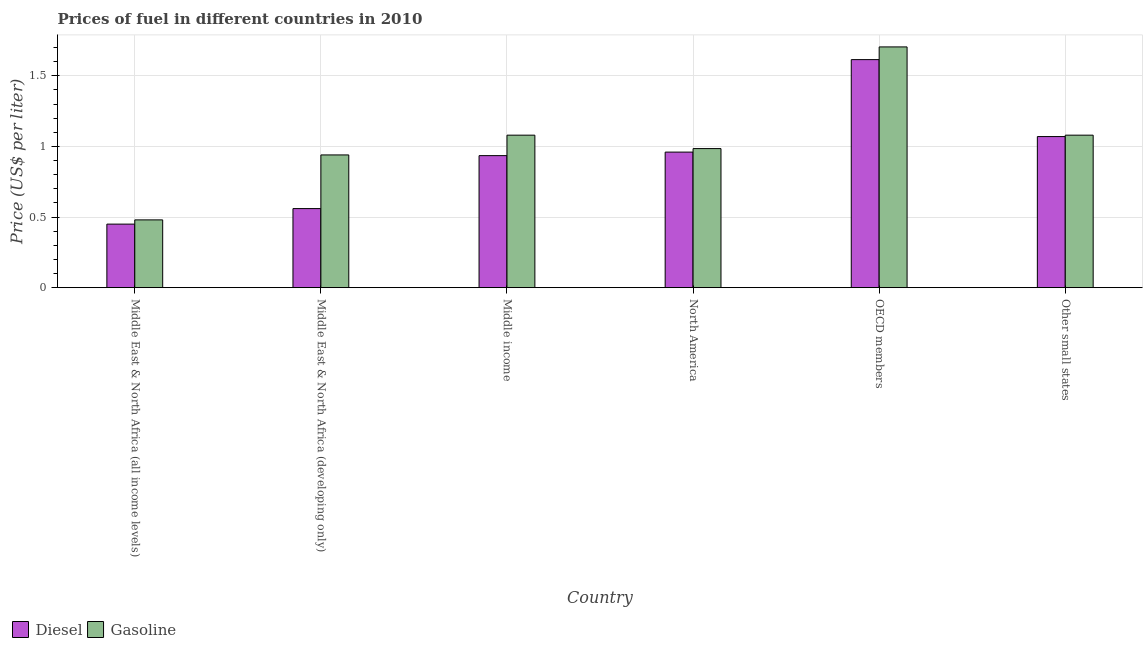How many different coloured bars are there?
Provide a succinct answer. 2. How many groups of bars are there?
Offer a terse response. 6. Are the number of bars per tick equal to the number of legend labels?
Provide a succinct answer. Yes. Are the number of bars on each tick of the X-axis equal?
Your response must be concise. Yes. What is the label of the 5th group of bars from the left?
Keep it short and to the point. OECD members. What is the gasoline price in Middle East & North Africa (all income levels)?
Offer a terse response. 0.48. Across all countries, what is the maximum diesel price?
Provide a short and direct response. 1.61. Across all countries, what is the minimum gasoline price?
Your answer should be very brief. 0.48. In which country was the gasoline price minimum?
Provide a short and direct response. Middle East & North Africa (all income levels). What is the total gasoline price in the graph?
Your response must be concise. 6.27. What is the difference between the gasoline price in Middle East & North Africa (all income levels) and that in OECD members?
Your answer should be compact. -1.23. What is the difference between the gasoline price in OECD members and the diesel price in Middle East & North Africa (all income levels)?
Your answer should be compact. 1.26. What is the average diesel price per country?
Your answer should be compact. 0.93. What is the difference between the diesel price and gasoline price in OECD members?
Make the answer very short. -0.09. In how many countries, is the diesel price greater than 1.3 US$ per litre?
Keep it short and to the point. 1. What is the ratio of the diesel price in Middle East & North Africa (all income levels) to that in Other small states?
Give a very brief answer. 0.42. Is the diesel price in Middle East & North Africa (all income levels) less than that in Middle income?
Make the answer very short. Yes. Is the difference between the gasoline price in North America and OECD members greater than the difference between the diesel price in North America and OECD members?
Give a very brief answer. No. What is the difference between the highest and the second highest diesel price?
Make the answer very short. 0.54. What is the difference between the highest and the lowest gasoline price?
Provide a short and direct response. 1.23. Is the sum of the diesel price in Middle East & North Africa (all income levels) and Middle East & North Africa (developing only) greater than the maximum gasoline price across all countries?
Keep it short and to the point. No. What does the 1st bar from the left in Other small states represents?
Your answer should be very brief. Diesel. What does the 2nd bar from the right in OECD members represents?
Give a very brief answer. Diesel. What is the difference between two consecutive major ticks on the Y-axis?
Provide a succinct answer. 0.5. Does the graph contain grids?
Give a very brief answer. Yes. Where does the legend appear in the graph?
Your response must be concise. Bottom left. How many legend labels are there?
Provide a succinct answer. 2. What is the title of the graph?
Ensure brevity in your answer.  Prices of fuel in different countries in 2010. Does "Borrowers" appear as one of the legend labels in the graph?
Provide a succinct answer. No. What is the label or title of the X-axis?
Make the answer very short. Country. What is the label or title of the Y-axis?
Offer a very short reply. Price (US$ per liter). What is the Price (US$ per liter) in Diesel in Middle East & North Africa (all income levels)?
Make the answer very short. 0.45. What is the Price (US$ per liter) of Gasoline in Middle East & North Africa (all income levels)?
Offer a terse response. 0.48. What is the Price (US$ per liter) in Diesel in Middle East & North Africa (developing only)?
Offer a very short reply. 0.56. What is the Price (US$ per liter) in Gasoline in Middle East & North Africa (developing only)?
Provide a succinct answer. 0.94. What is the Price (US$ per liter) of Diesel in Middle income?
Keep it short and to the point. 0.94. What is the Price (US$ per liter) of Gasoline in Middle income?
Provide a succinct answer. 1.08. What is the Price (US$ per liter) in Diesel in North America?
Offer a terse response. 0.96. What is the Price (US$ per liter) in Gasoline in North America?
Make the answer very short. 0.98. What is the Price (US$ per liter) in Diesel in OECD members?
Provide a short and direct response. 1.61. What is the Price (US$ per liter) of Gasoline in OECD members?
Your answer should be very brief. 1.71. What is the Price (US$ per liter) of Diesel in Other small states?
Your answer should be compact. 1.07. Across all countries, what is the maximum Price (US$ per liter) in Diesel?
Provide a short and direct response. 1.61. Across all countries, what is the maximum Price (US$ per liter) of Gasoline?
Keep it short and to the point. 1.71. Across all countries, what is the minimum Price (US$ per liter) in Diesel?
Provide a succinct answer. 0.45. Across all countries, what is the minimum Price (US$ per liter) in Gasoline?
Your answer should be compact. 0.48. What is the total Price (US$ per liter) of Diesel in the graph?
Your answer should be very brief. 5.59. What is the total Price (US$ per liter) of Gasoline in the graph?
Your response must be concise. 6.27. What is the difference between the Price (US$ per liter) in Diesel in Middle East & North Africa (all income levels) and that in Middle East & North Africa (developing only)?
Offer a terse response. -0.11. What is the difference between the Price (US$ per liter) of Gasoline in Middle East & North Africa (all income levels) and that in Middle East & North Africa (developing only)?
Provide a short and direct response. -0.46. What is the difference between the Price (US$ per liter) of Diesel in Middle East & North Africa (all income levels) and that in Middle income?
Make the answer very short. -0.48. What is the difference between the Price (US$ per liter) of Gasoline in Middle East & North Africa (all income levels) and that in Middle income?
Give a very brief answer. -0.6. What is the difference between the Price (US$ per liter) of Diesel in Middle East & North Africa (all income levels) and that in North America?
Make the answer very short. -0.51. What is the difference between the Price (US$ per liter) of Gasoline in Middle East & North Africa (all income levels) and that in North America?
Offer a terse response. -0.51. What is the difference between the Price (US$ per liter) in Diesel in Middle East & North Africa (all income levels) and that in OECD members?
Your response must be concise. -1.17. What is the difference between the Price (US$ per liter) in Gasoline in Middle East & North Africa (all income levels) and that in OECD members?
Your answer should be very brief. -1.23. What is the difference between the Price (US$ per liter) in Diesel in Middle East & North Africa (all income levels) and that in Other small states?
Keep it short and to the point. -0.62. What is the difference between the Price (US$ per liter) of Diesel in Middle East & North Africa (developing only) and that in Middle income?
Your answer should be very brief. -0.38. What is the difference between the Price (US$ per liter) of Gasoline in Middle East & North Africa (developing only) and that in Middle income?
Offer a terse response. -0.14. What is the difference between the Price (US$ per liter) of Diesel in Middle East & North Africa (developing only) and that in North America?
Make the answer very short. -0.4. What is the difference between the Price (US$ per liter) in Gasoline in Middle East & North Africa (developing only) and that in North America?
Make the answer very short. -0.04. What is the difference between the Price (US$ per liter) in Diesel in Middle East & North Africa (developing only) and that in OECD members?
Offer a terse response. -1.05. What is the difference between the Price (US$ per liter) in Gasoline in Middle East & North Africa (developing only) and that in OECD members?
Offer a terse response. -0.77. What is the difference between the Price (US$ per liter) of Diesel in Middle East & North Africa (developing only) and that in Other small states?
Your answer should be compact. -0.51. What is the difference between the Price (US$ per liter) in Gasoline in Middle East & North Africa (developing only) and that in Other small states?
Give a very brief answer. -0.14. What is the difference between the Price (US$ per liter) in Diesel in Middle income and that in North America?
Provide a succinct answer. -0.03. What is the difference between the Price (US$ per liter) of Gasoline in Middle income and that in North America?
Make the answer very short. 0.1. What is the difference between the Price (US$ per liter) of Diesel in Middle income and that in OECD members?
Offer a terse response. -0.68. What is the difference between the Price (US$ per liter) in Gasoline in Middle income and that in OECD members?
Your answer should be very brief. -0.62. What is the difference between the Price (US$ per liter) of Diesel in Middle income and that in Other small states?
Keep it short and to the point. -0.14. What is the difference between the Price (US$ per liter) of Diesel in North America and that in OECD members?
Keep it short and to the point. -0.66. What is the difference between the Price (US$ per liter) in Gasoline in North America and that in OECD members?
Make the answer very short. -0.72. What is the difference between the Price (US$ per liter) of Diesel in North America and that in Other small states?
Your answer should be very brief. -0.11. What is the difference between the Price (US$ per liter) of Gasoline in North America and that in Other small states?
Provide a succinct answer. -0.1. What is the difference between the Price (US$ per liter) in Diesel in OECD members and that in Other small states?
Your response must be concise. 0.55. What is the difference between the Price (US$ per liter) in Gasoline in OECD members and that in Other small states?
Your response must be concise. 0.62. What is the difference between the Price (US$ per liter) in Diesel in Middle East & North Africa (all income levels) and the Price (US$ per liter) in Gasoline in Middle East & North Africa (developing only)?
Offer a terse response. -0.49. What is the difference between the Price (US$ per liter) in Diesel in Middle East & North Africa (all income levels) and the Price (US$ per liter) in Gasoline in Middle income?
Your response must be concise. -0.63. What is the difference between the Price (US$ per liter) in Diesel in Middle East & North Africa (all income levels) and the Price (US$ per liter) in Gasoline in North America?
Your answer should be compact. -0.54. What is the difference between the Price (US$ per liter) in Diesel in Middle East & North Africa (all income levels) and the Price (US$ per liter) in Gasoline in OECD members?
Offer a very short reply. -1.25. What is the difference between the Price (US$ per liter) in Diesel in Middle East & North Africa (all income levels) and the Price (US$ per liter) in Gasoline in Other small states?
Offer a very short reply. -0.63. What is the difference between the Price (US$ per liter) of Diesel in Middle East & North Africa (developing only) and the Price (US$ per liter) of Gasoline in Middle income?
Your response must be concise. -0.52. What is the difference between the Price (US$ per liter) in Diesel in Middle East & North Africa (developing only) and the Price (US$ per liter) in Gasoline in North America?
Ensure brevity in your answer.  -0.42. What is the difference between the Price (US$ per liter) of Diesel in Middle East & North Africa (developing only) and the Price (US$ per liter) of Gasoline in OECD members?
Ensure brevity in your answer.  -1.15. What is the difference between the Price (US$ per liter) in Diesel in Middle East & North Africa (developing only) and the Price (US$ per liter) in Gasoline in Other small states?
Give a very brief answer. -0.52. What is the difference between the Price (US$ per liter) in Diesel in Middle income and the Price (US$ per liter) in Gasoline in OECD members?
Your response must be concise. -0.77. What is the difference between the Price (US$ per liter) of Diesel in Middle income and the Price (US$ per liter) of Gasoline in Other small states?
Offer a very short reply. -0.14. What is the difference between the Price (US$ per liter) of Diesel in North America and the Price (US$ per liter) of Gasoline in OECD members?
Provide a short and direct response. -0.74. What is the difference between the Price (US$ per liter) of Diesel in North America and the Price (US$ per liter) of Gasoline in Other small states?
Make the answer very short. -0.12. What is the difference between the Price (US$ per liter) of Diesel in OECD members and the Price (US$ per liter) of Gasoline in Other small states?
Give a very brief answer. 0.54. What is the average Price (US$ per liter) in Diesel per country?
Ensure brevity in your answer.  0.93. What is the average Price (US$ per liter) in Gasoline per country?
Give a very brief answer. 1.04. What is the difference between the Price (US$ per liter) of Diesel and Price (US$ per liter) of Gasoline in Middle East & North Africa (all income levels)?
Make the answer very short. -0.03. What is the difference between the Price (US$ per liter) of Diesel and Price (US$ per liter) of Gasoline in Middle East & North Africa (developing only)?
Your response must be concise. -0.38. What is the difference between the Price (US$ per liter) of Diesel and Price (US$ per liter) of Gasoline in Middle income?
Keep it short and to the point. -0.14. What is the difference between the Price (US$ per liter) of Diesel and Price (US$ per liter) of Gasoline in North America?
Your answer should be compact. -0.03. What is the difference between the Price (US$ per liter) in Diesel and Price (US$ per liter) in Gasoline in OECD members?
Offer a very short reply. -0.09. What is the difference between the Price (US$ per liter) in Diesel and Price (US$ per liter) in Gasoline in Other small states?
Ensure brevity in your answer.  -0.01. What is the ratio of the Price (US$ per liter) in Diesel in Middle East & North Africa (all income levels) to that in Middle East & North Africa (developing only)?
Offer a very short reply. 0.8. What is the ratio of the Price (US$ per liter) of Gasoline in Middle East & North Africa (all income levels) to that in Middle East & North Africa (developing only)?
Your answer should be compact. 0.51. What is the ratio of the Price (US$ per liter) of Diesel in Middle East & North Africa (all income levels) to that in Middle income?
Make the answer very short. 0.48. What is the ratio of the Price (US$ per liter) in Gasoline in Middle East & North Africa (all income levels) to that in Middle income?
Offer a very short reply. 0.44. What is the ratio of the Price (US$ per liter) in Diesel in Middle East & North Africa (all income levels) to that in North America?
Provide a succinct answer. 0.47. What is the ratio of the Price (US$ per liter) of Gasoline in Middle East & North Africa (all income levels) to that in North America?
Offer a terse response. 0.49. What is the ratio of the Price (US$ per liter) in Diesel in Middle East & North Africa (all income levels) to that in OECD members?
Keep it short and to the point. 0.28. What is the ratio of the Price (US$ per liter) in Gasoline in Middle East & North Africa (all income levels) to that in OECD members?
Provide a succinct answer. 0.28. What is the ratio of the Price (US$ per liter) in Diesel in Middle East & North Africa (all income levels) to that in Other small states?
Offer a terse response. 0.42. What is the ratio of the Price (US$ per liter) of Gasoline in Middle East & North Africa (all income levels) to that in Other small states?
Your answer should be very brief. 0.44. What is the ratio of the Price (US$ per liter) of Diesel in Middle East & North Africa (developing only) to that in Middle income?
Give a very brief answer. 0.6. What is the ratio of the Price (US$ per liter) in Gasoline in Middle East & North Africa (developing only) to that in Middle income?
Provide a short and direct response. 0.87. What is the ratio of the Price (US$ per liter) of Diesel in Middle East & North Africa (developing only) to that in North America?
Offer a terse response. 0.58. What is the ratio of the Price (US$ per liter) of Gasoline in Middle East & North Africa (developing only) to that in North America?
Your response must be concise. 0.95. What is the ratio of the Price (US$ per liter) of Diesel in Middle East & North Africa (developing only) to that in OECD members?
Make the answer very short. 0.35. What is the ratio of the Price (US$ per liter) of Gasoline in Middle East & North Africa (developing only) to that in OECD members?
Ensure brevity in your answer.  0.55. What is the ratio of the Price (US$ per liter) of Diesel in Middle East & North Africa (developing only) to that in Other small states?
Keep it short and to the point. 0.52. What is the ratio of the Price (US$ per liter) in Gasoline in Middle East & North Africa (developing only) to that in Other small states?
Offer a terse response. 0.87. What is the ratio of the Price (US$ per liter) of Diesel in Middle income to that in North America?
Your response must be concise. 0.97. What is the ratio of the Price (US$ per liter) of Gasoline in Middle income to that in North America?
Provide a short and direct response. 1.1. What is the ratio of the Price (US$ per liter) of Diesel in Middle income to that in OECD members?
Your answer should be compact. 0.58. What is the ratio of the Price (US$ per liter) in Gasoline in Middle income to that in OECD members?
Provide a succinct answer. 0.63. What is the ratio of the Price (US$ per liter) in Diesel in Middle income to that in Other small states?
Your response must be concise. 0.87. What is the ratio of the Price (US$ per liter) in Gasoline in Middle income to that in Other small states?
Your response must be concise. 1. What is the ratio of the Price (US$ per liter) in Diesel in North America to that in OECD members?
Ensure brevity in your answer.  0.59. What is the ratio of the Price (US$ per liter) of Gasoline in North America to that in OECD members?
Make the answer very short. 0.58. What is the ratio of the Price (US$ per liter) of Diesel in North America to that in Other small states?
Offer a very short reply. 0.9. What is the ratio of the Price (US$ per liter) in Gasoline in North America to that in Other small states?
Provide a short and direct response. 0.91. What is the ratio of the Price (US$ per liter) of Diesel in OECD members to that in Other small states?
Ensure brevity in your answer.  1.51. What is the ratio of the Price (US$ per liter) of Gasoline in OECD members to that in Other small states?
Make the answer very short. 1.58. What is the difference between the highest and the second highest Price (US$ per liter) of Diesel?
Give a very brief answer. 0.55. What is the difference between the highest and the lowest Price (US$ per liter) in Diesel?
Keep it short and to the point. 1.17. What is the difference between the highest and the lowest Price (US$ per liter) in Gasoline?
Provide a succinct answer. 1.23. 